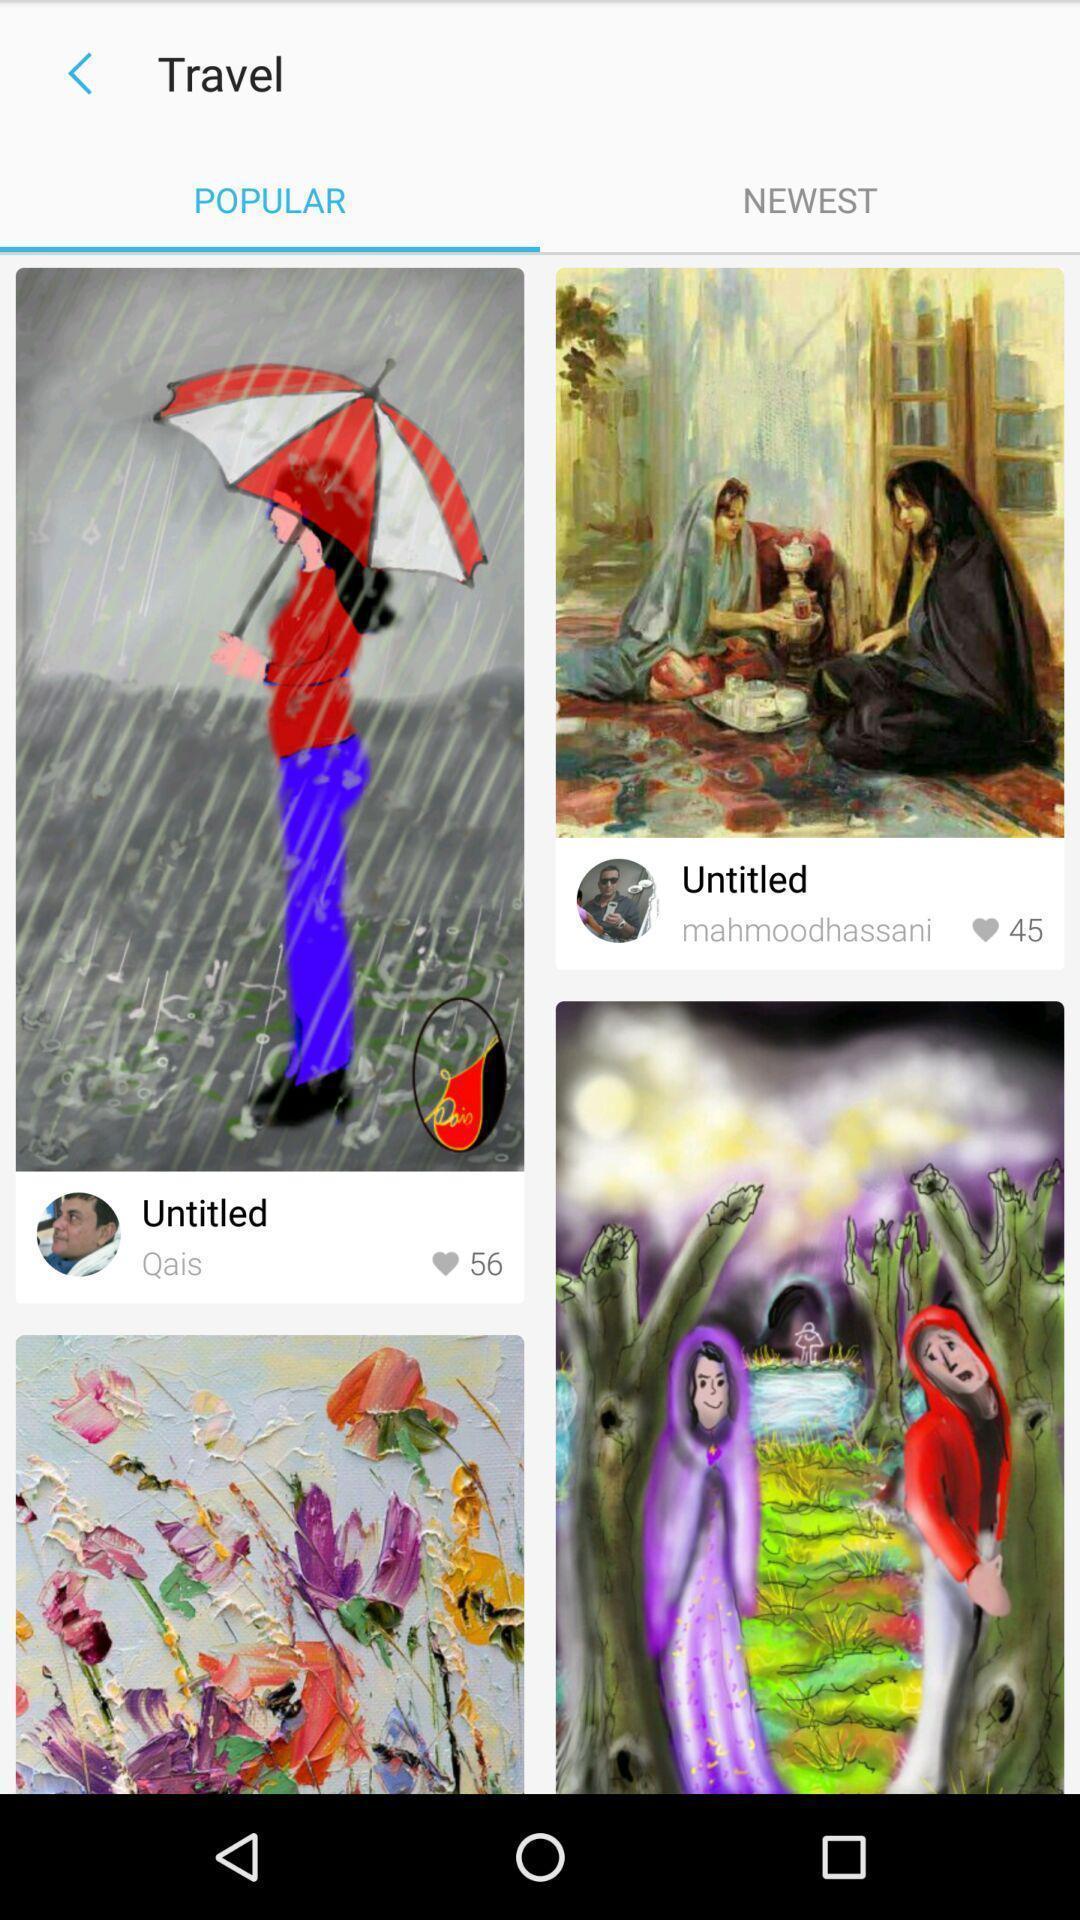Summarize the information in this screenshot. Screen shows popular images. 